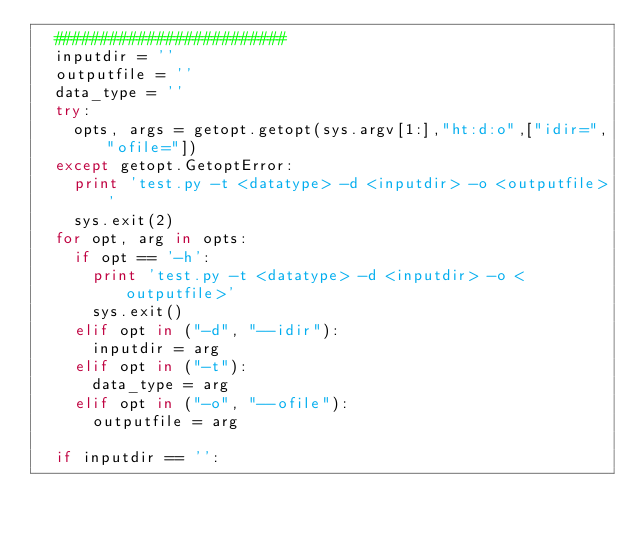<code> <loc_0><loc_0><loc_500><loc_500><_Python_>	#########################
	inputdir = ''
	outputfile = ''
	data_type = ''
	try:
		opts, args = getopt.getopt(sys.argv[1:],"ht:d:o",["idir=","ofile="])
	except getopt.GetoptError:
		print 'test.py -t <datatype> -d <inputdir> -o <outputfile>'
		sys.exit(2)
	for opt, arg in opts:
		if opt == '-h':
			print 'test.py -t <datatype> -d <inputdir> -o <outputfile>'
			sys.exit()
		elif opt in ("-d", "--idir"):
			inputdir = arg
		elif opt in ("-t"):
			data_type = arg
		elif opt in ("-o", "--ofile"):
			outputfile = arg

	if inputdir == '':</code> 